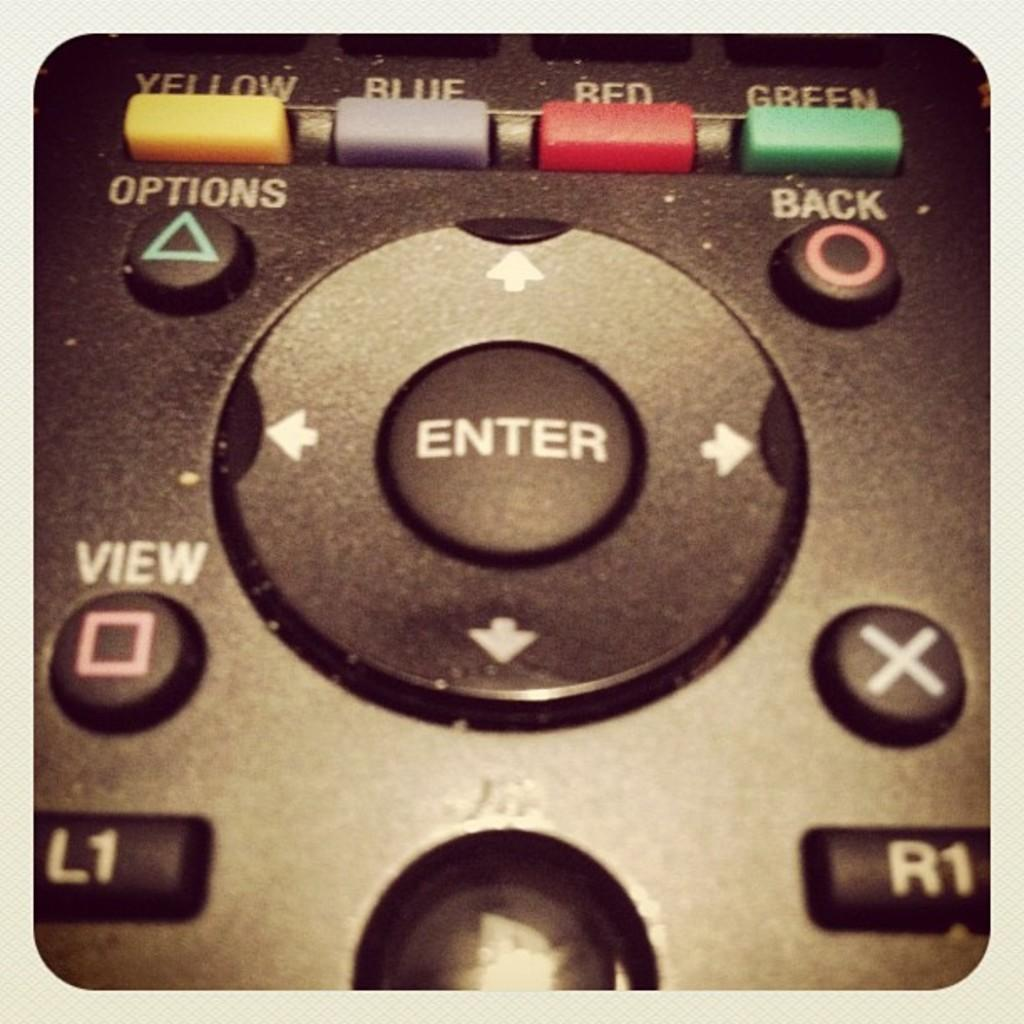<image>
Share a concise interpretation of the image provided. Underneath a yellow, blue, red, and green button of a remote control is a round button with arrows on all sides and an enter button in the center. 